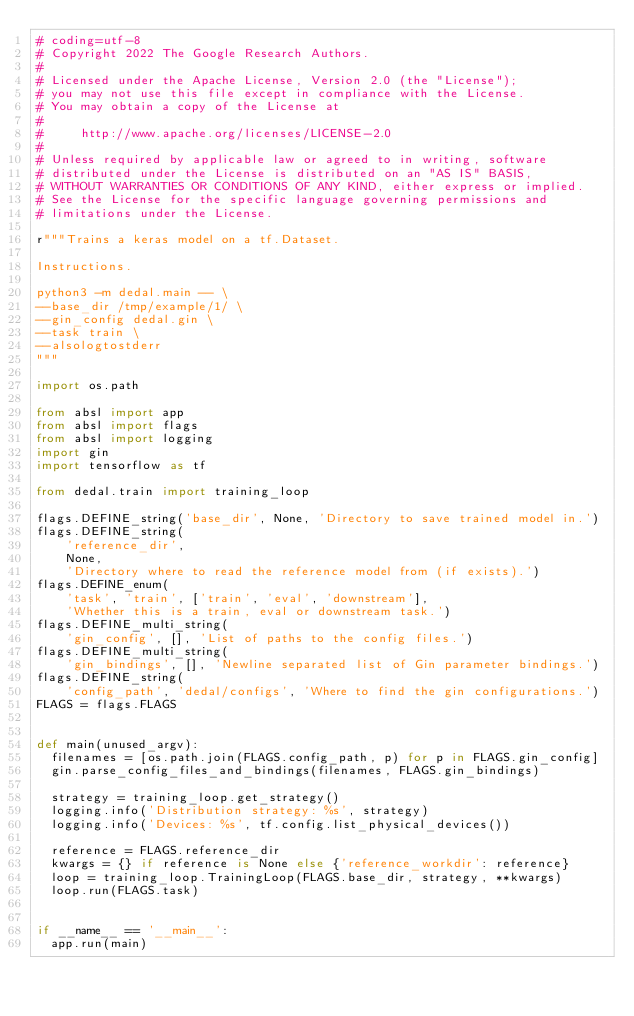<code> <loc_0><loc_0><loc_500><loc_500><_Python_># coding=utf-8
# Copyright 2022 The Google Research Authors.
#
# Licensed under the Apache License, Version 2.0 (the "License");
# you may not use this file except in compliance with the License.
# You may obtain a copy of the License at
#
#     http://www.apache.org/licenses/LICENSE-2.0
#
# Unless required by applicable law or agreed to in writing, software
# distributed under the License is distributed on an "AS IS" BASIS,
# WITHOUT WARRANTIES OR CONDITIONS OF ANY KIND, either express or implied.
# See the License for the specific language governing permissions and
# limitations under the License.

r"""Trains a keras model on a tf.Dataset.

Instructions.

python3 -m dedal.main -- \
--base_dir /tmp/example/1/ \
--gin_config dedal.gin \
--task train \
--alsologtostderr
"""

import os.path

from absl import app
from absl import flags
from absl import logging
import gin
import tensorflow as tf

from dedal.train import training_loop

flags.DEFINE_string('base_dir', None, 'Directory to save trained model in.')
flags.DEFINE_string(
    'reference_dir',
    None,
    'Directory where to read the reference model from (if exists).')
flags.DEFINE_enum(
    'task', 'train', ['train', 'eval', 'downstream'],
    'Whether this is a train, eval or downstream task.')
flags.DEFINE_multi_string(
    'gin_config', [], 'List of paths to the config files.')
flags.DEFINE_multi_string(
    'gin_bindings', [], 'Newline separated list of Gin parameter bindings.')
flags.DEFINE_string(
    'config_path', 'dedal/configs', 'Where to find the gin configurations.')
FLAGS = flags.FLAGS


def main(unused_argv):
  filenames = [os.path.join(FLAGS.config_path, p) for p in FLAGS.gin_config]
  gin.parse_config_files_and_bindings(filenames, FLAGS.gin_bindings)

  strategy = training_loop.get_strategy()
  logging.info('Distribution strategy: %s', strategy)
  logging.info('Devices: %s', tf.config.list_physical_devices())

  reference = FLAGS.reference_dir
  kwargs = {} if reference is None else {'reference_workdir': reference}
  loop = training_loop.TrainingLoop(FLAGS.base_dir, strategy, **kwargs)
  loop.run(FLAGS.task)


if __name__ == '__main__':
  app.run(main)
</code> 